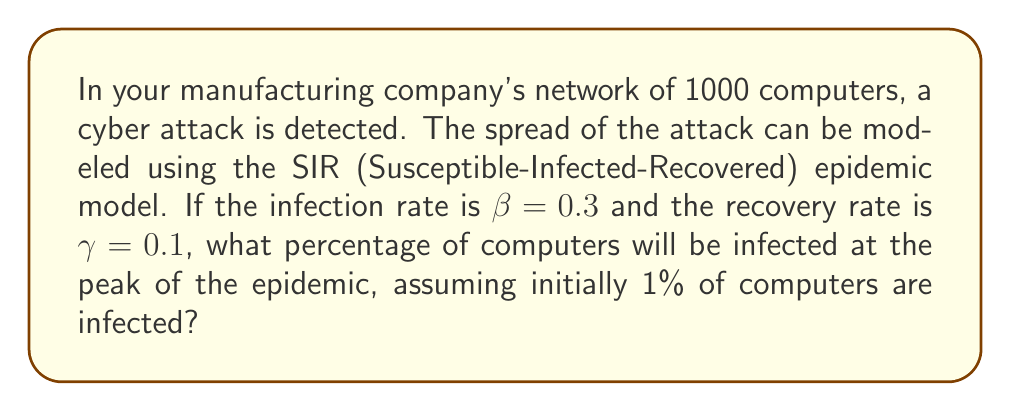Can you solve this math problem? To solve this problem, we'll use the SIR model and find the maximum of the infected population:

1) In the SIR model, the fraction of infected computers at the peak occurs when:

   $$\frac{dI}{dt} = 0$$

2) This happens when:

   $$S = \frac{\gamma}{\beta}$$

3) We know that $S + I + R = 1$ (total population fraction). At the start:
   
   $S_0 = 0.99$, $I_0 = 0.01$, $R_0 = 0$

4) The final size equation in the SIR model is:

   $$\ln\left(\frac{S_\infty}{S_0}\right) = R_0(S_\infty - 1)$$

   Where $R_0 = \frac{\beta}{\gamma} = \frac{0.3}{0.1} = 3$

5) Solving numerically, we get $S_\infty \approx 0.0595$

6) At the peak, $S = \frac{\gamma}{\beta} = \frac{1}{R_0} = \frac{1}{3} \approx 0.3333$

7) The fraction of recovered at this point is:

   $$R = 1 - S - I = 1 - 0.3333 - 0.0595 \approx 0.6072$$

8) Therefore, the fraction infected at the peak is:

   $$I_{peak} = 1 - S - R = 1 - 0.3333 - 0.6072 \approx 0.0595$$

9) Converting to a percentage:

   $$0.0595 * 100\% \approx 5.95\%$$
Answer: 5.95% 